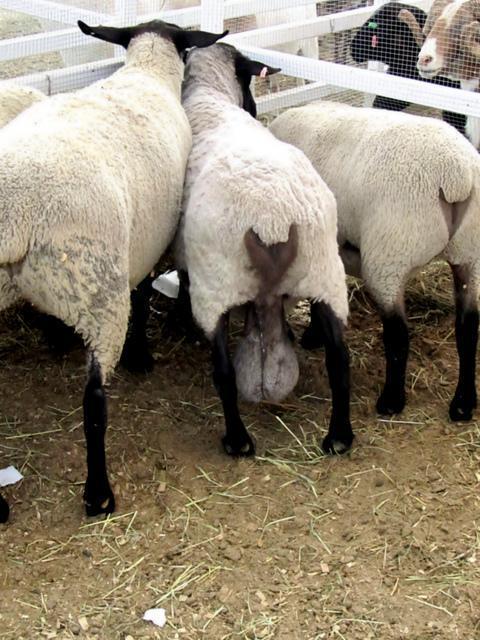What is hanging on the belly of the sheep in the middle?
Pick the right solution, then justify: 'Answer: answer
Rationale: rationale.'
Options: Bell, udder, gong, saddle. Answer: udder.
Rationale: The hanging object is the sheep's mammary gland. 